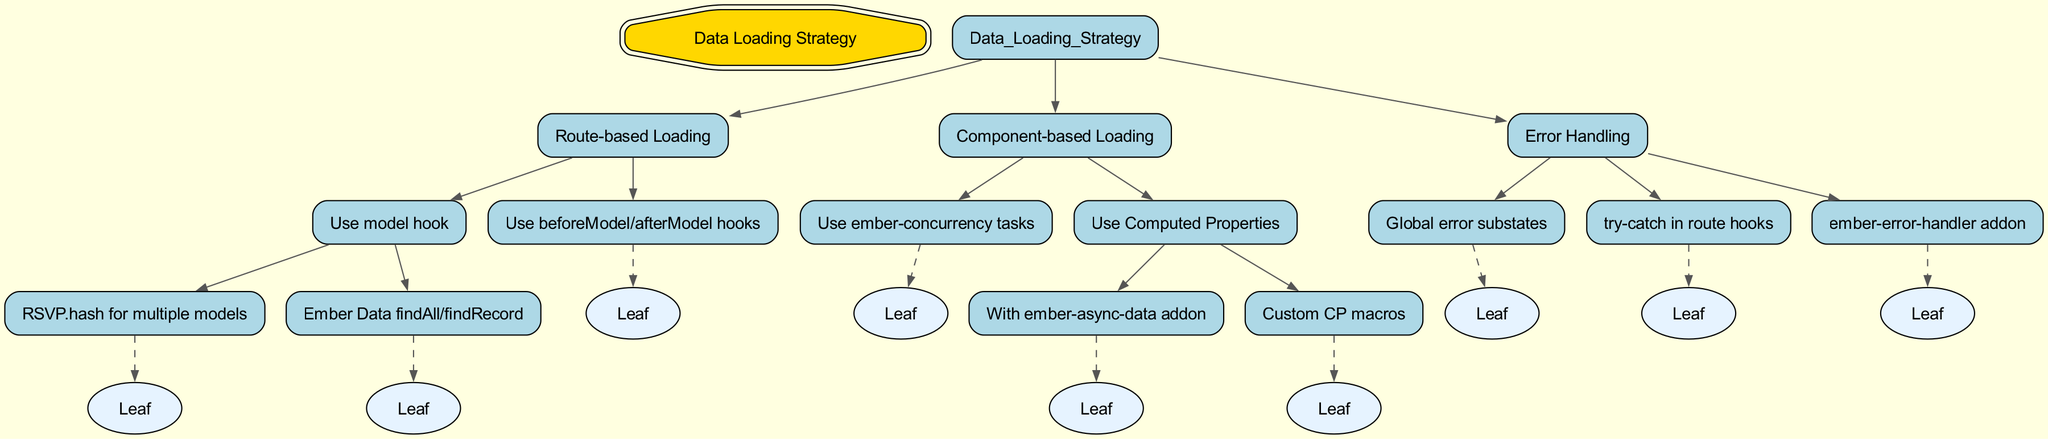What is the root of the decision tree? The root node of the decision tree is labeled "Data Loading Strategy." This is indicated at the top of the diagram.
Answer: Data Loading Strategy How many main strategies are there for data loading? The diagram branches into three main strategies: Route-based Loading, Component-based Loading, and Error Handling. Thus, there are three main strategies.
Answer: 3 Which method is part of Route-based Loading? One method listed under Route-based Loading is "Use model hook." This node is one of the child nodes under the Route-based Loading section.
Answer: Use model hook What is one way to handle data loading with computed properties? The diagram indicates that "With ember-async-data addon" is a method available under the Component-based Loading section specifically discussing computed properties.
Answer: With ember-async-data addon What type of error handling is mentioned in the decision tree? The decision tree includes several error handling options, such as "Global error substates," indicating a method used to handle error states across the application.
Answer: Global error substates How can errors be handled in route hooks? The diagram specifies that using "try-catch in route hooks" is a method available for error handling, showing the relationship between error handling techniques and their integration in route management.
Answer: try-catch in route hooks Which loading strategy has the option to use RSVP.hash? The loading strategy described as "Use model hook" under Route-based Loading allows for the use of RSVP.hash for loading multiple models, connecting the specific loading approach to handling multiple dataset requests.
Answer: Use model hook What is a leaf node related to Component-based Loading? One of the leaf nodes is "Use ember-concurrency tasks," which indicates a specific method available for managing loading states at the component level without further branching.
Answer: Use ember-concurrency tasks Which addon is mentioned for error handling? The diagram lists "ember-error-handler addon" as one of the options within the Error Handling category, representing a tool specifically designed to manage errors in Ember applications.
Answer: ember-error-handler addon 